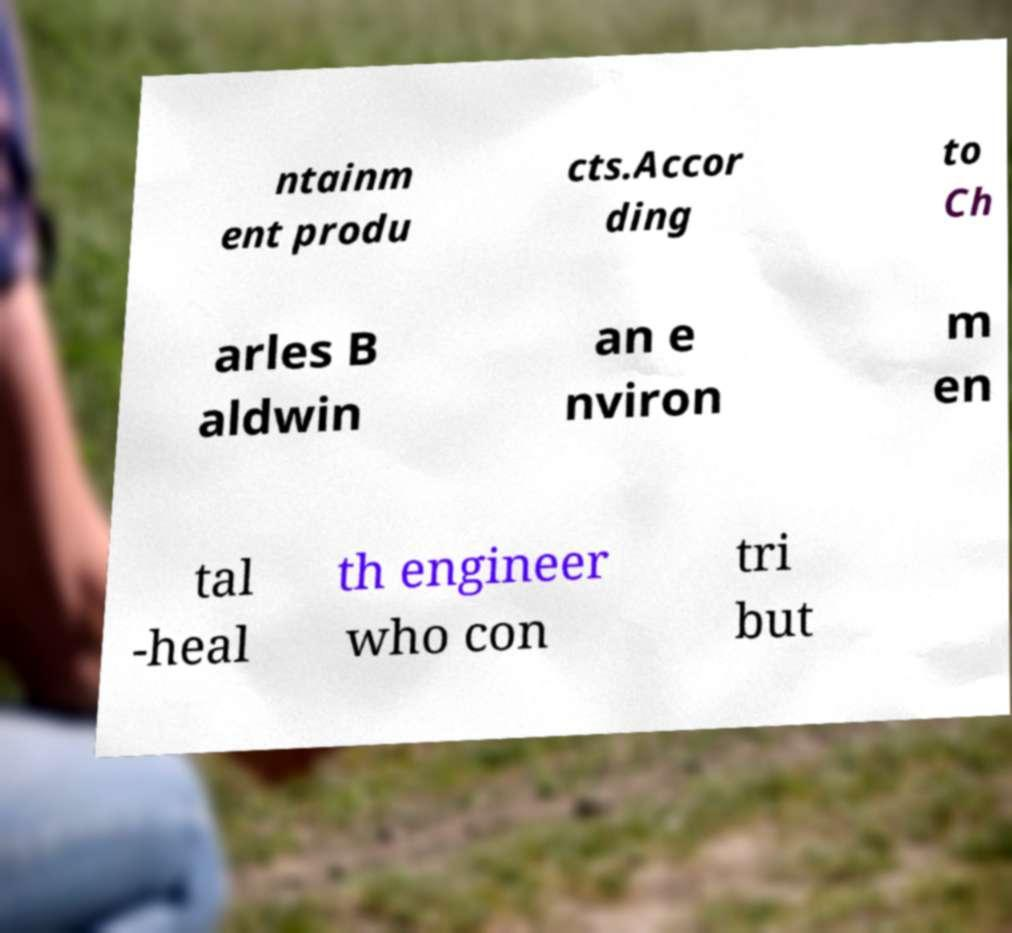Could you extract and type out the text from this image? ntainm ent produ cts.Accor ding to Ch arles B aldwin an e nviron m en tal -heal th engineer who con tri but 